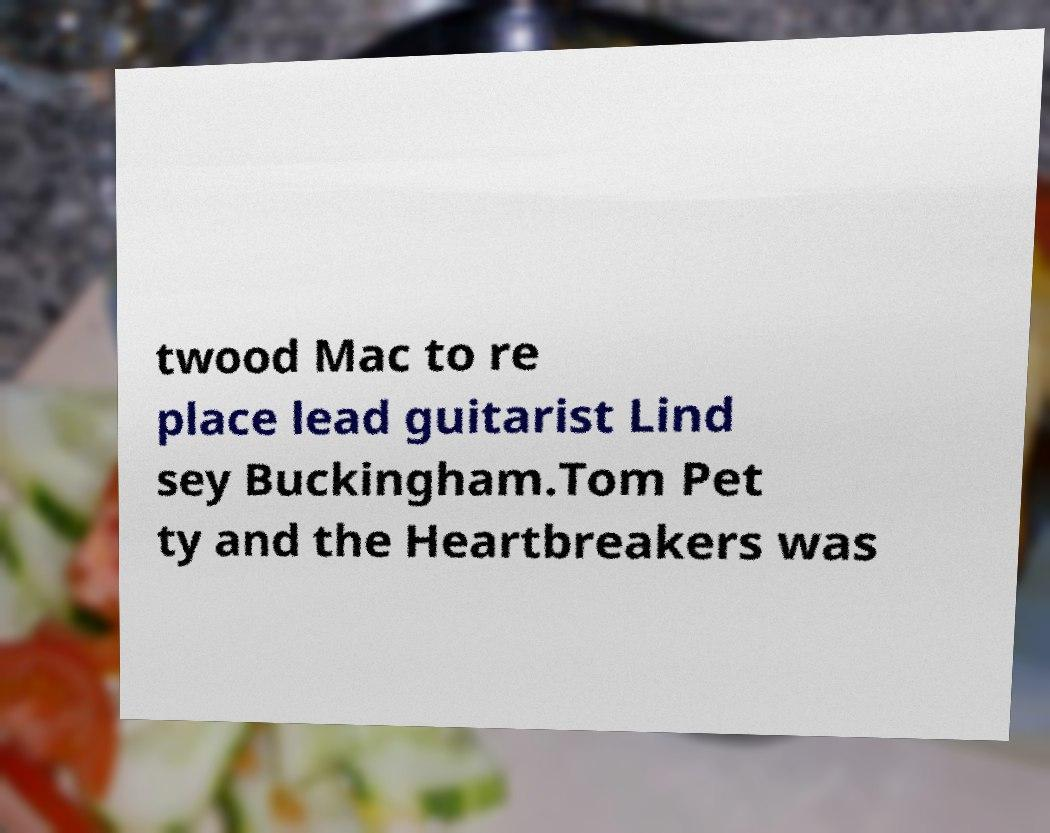Could you assist in decoding the text presented in this image and type it out clearly? twood Mac to re place lead guitarist Lind sey Buckingham.Tom Pet ty and the Heartbreakers was 